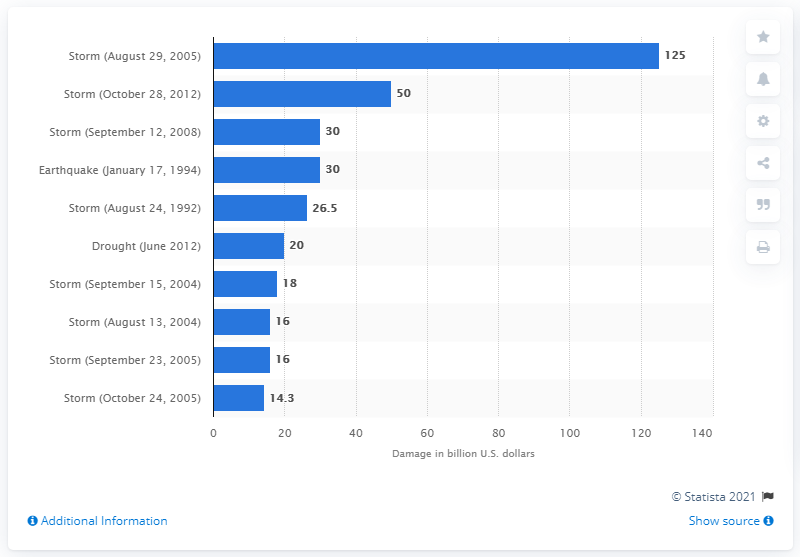Specify some key components in this picture. Hurricane Katrina caused an estimated $125 billion in damages in 2005. 